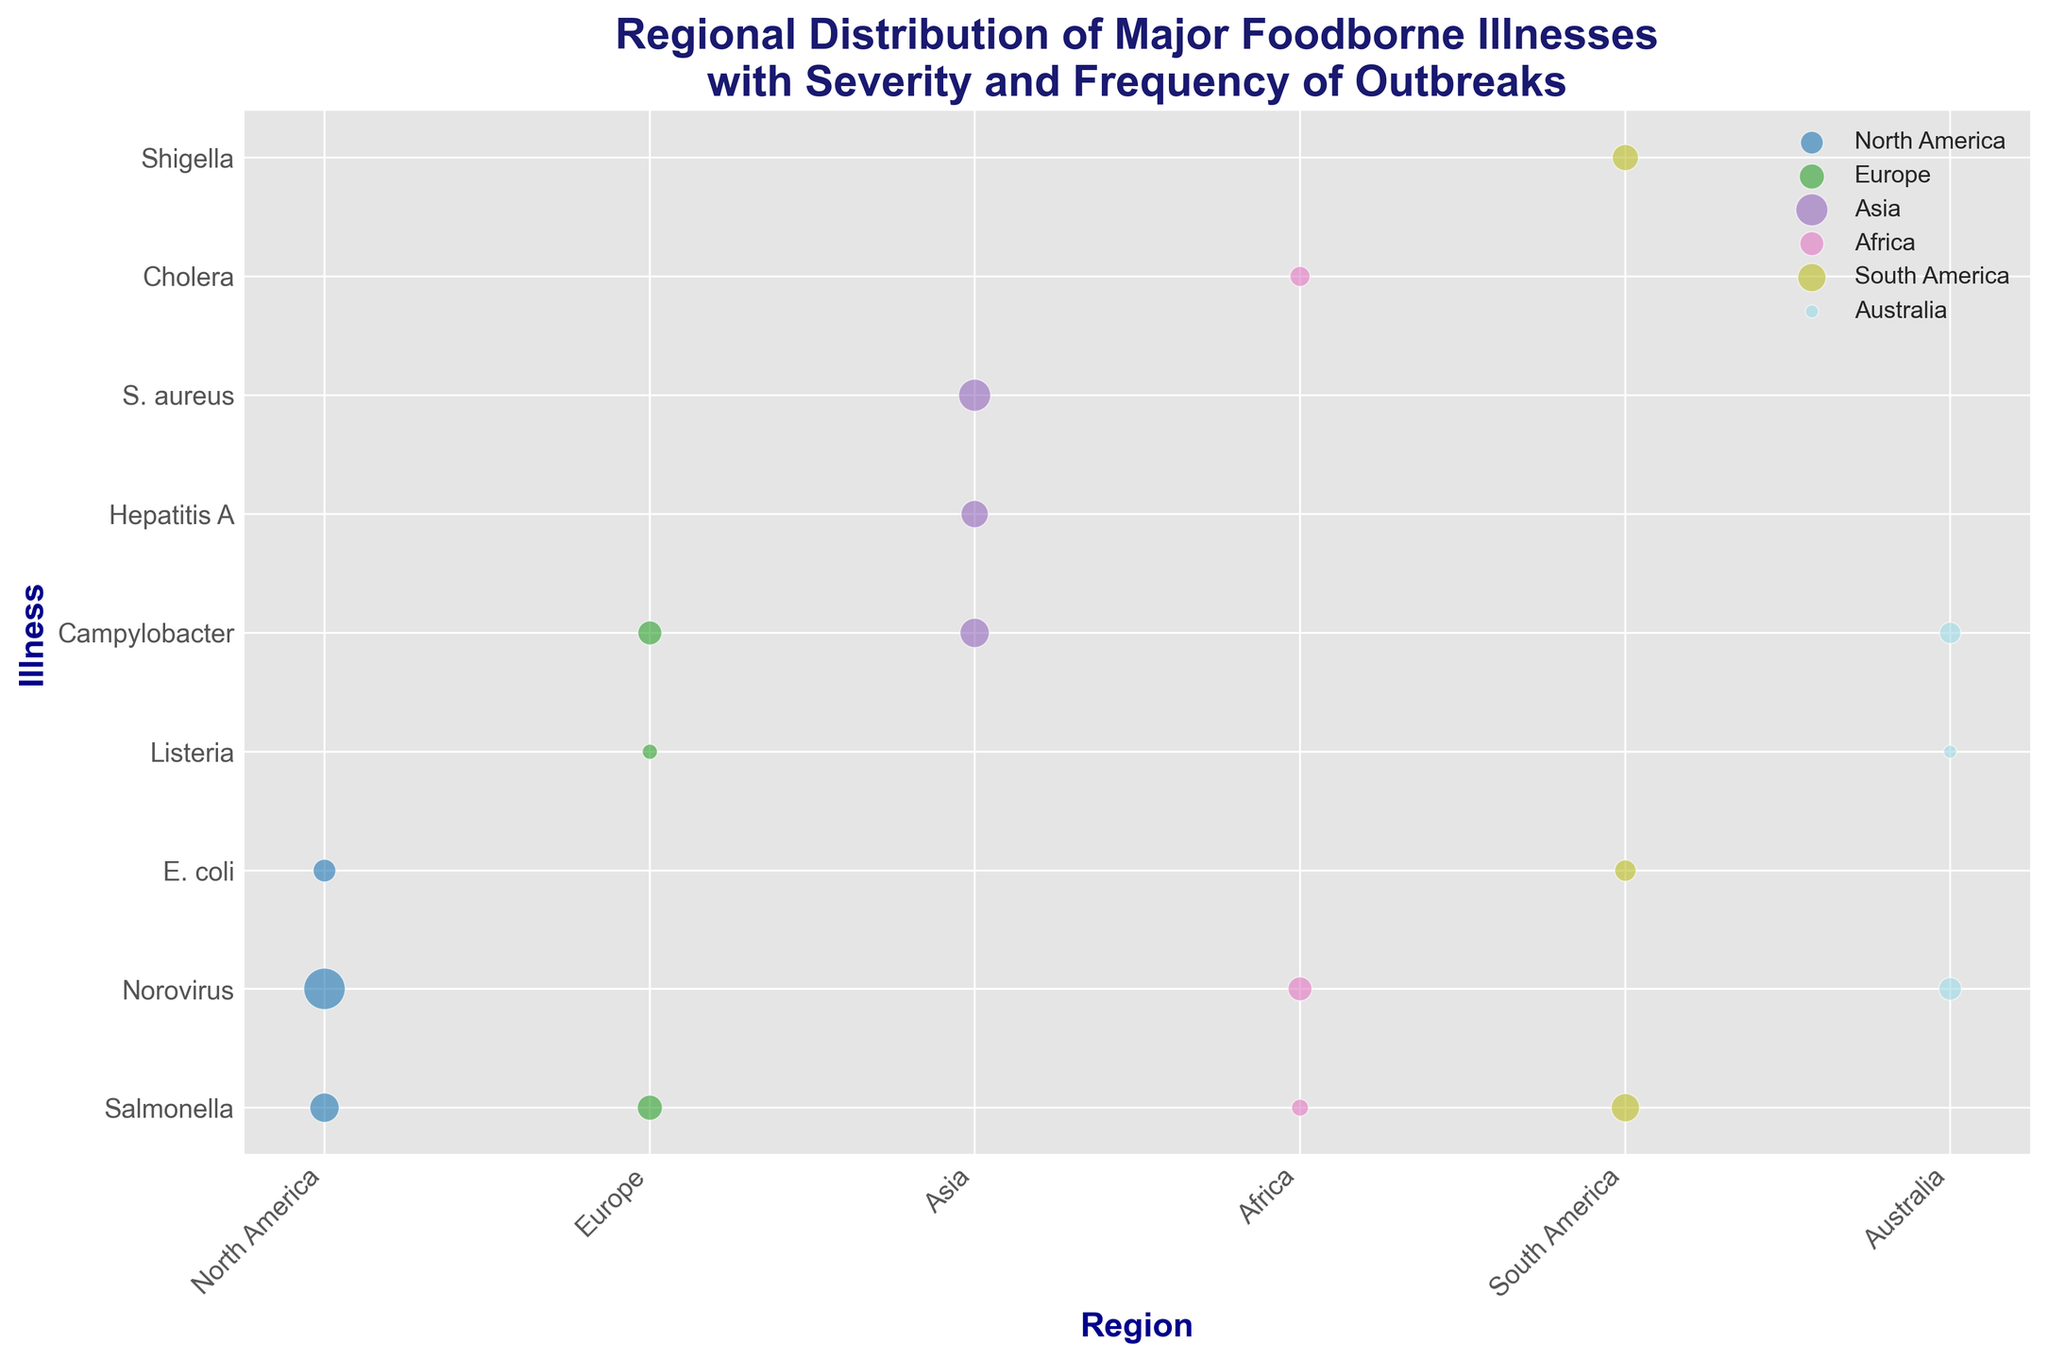What region has the highest frequency of Norovirus outbreaks? To determine this, look at the size of the bubbles labeled "Norovirus" across all regions and identify the largest one. The largest bubble indicates the highest frequency of outbreaks.
Answer: North America Which illness has the highest severity in Africa? Check the bubbles with "Africa" on the x-axis and observe their y-axis positions, representing different illnesses. The bubble highest on the y-axis has the highest severity.
Answer: Cholera How does the severity of Campylobacter compare between Europe and Australia? Locate the bubbles representing Campylobacter in Europe and Australia. Check the y-axis values for both. Europe has a Campylobacter severity of 6, while Australia has the same.
Answer: Equal What's the average frequency of Salmonella outbreaks across all regions? Find the bubbles labeled "Salmonella" for each region and sum their sizes: North America (150), Europe (110), Africa (50), and South America (140). Then calculate the average: (150 + 110 + 50 + 140) / 4 = 112.5
Answer: 112.5 Which region has the smallest bubble for Listeria, and what does this indicate? Compare the sizes of the bubbles labeled "Listeria" across different regions. The smallest Listeria bubble represents the region with the lowest frequency of Listeria outbreaks.
Answer: Australia Is the severity of Hepatitis A higher or lower than S. aureus in Asia? Look at the y-axis positions for bubbles labeled Hepatitis A and S. aureus in Asia. Hepatitis A has a severity of 5, while S. aureus has a severity of 4.
Answer: Higher What is the total frequency of foodborne illness outbreaks in South America? Sum the sizes of all bubbles in the South America region. E. coli (80), Shigella (120), and Salmonella (140). (80 + 120 + 140) = 340
Answer: 340 Compare the frequency of Norovirus outbreaks between North America and Africa. Which region has more? Check the size of the bubbles labeled "Norovirus" in both North America and Africa. North America's frequency is 300, whereas Africa's is 100.
Answer: North America Which illness has the highest frequency in Asia? Look at the size of the bubbles in the Asia region and determine which one is the largest. The largest bubble indicates the highest frequency.
Answer: S. aureus Between North America and Europe, which region has a higher average severity of illnesses? Calculate the average severity for each region. For North America: (7 + 5 + 8) / 3 = 6.67. For Europe: (9 + 6 + 7) / 3 = 7.33.
Answer: Europe 